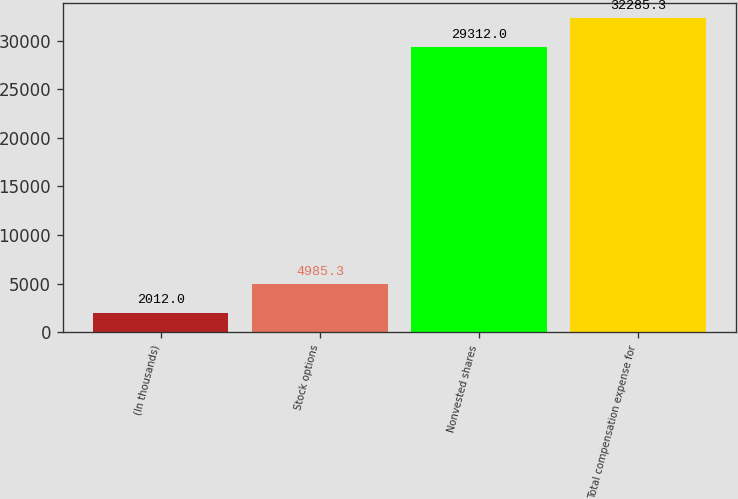Convert chart to OTSL. <chart><loc_0><loc_0><loc_500><loc_500><bar_chart><fcel>(In thousands)<fcel>Stock options<fcel>Nonvested shares<fcel>Total compensation expense for<nl><fcel>2012<fcel>4985.3<fcel>29312<fcel>32285.3<nl></chart> 